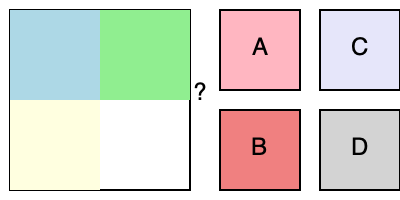Which puzzle piece (A, B, C, or D) correctly completes the jigsaw pattern? Let's approach this step-by-step:

1. Observe the existing pattern:
   - Top-left: Light blue
   - Top-right: Light green
   - Bottom-left: Light yellow
   - Bottom-right: Missing piece (marked with "?")

2. Look for a logical color pattern:
   - The colors are getting progressively lighter and warmer from left to right and top to bottom.

3. Examine the options:
   - A: Light pink
   - B: Light coral (a warmer, more orange-toned pink)
   - C: Lavender (a cool, light purple)
   - D: Light grey

4. Apply the pattern logic:
   - The missing piece should be warmer and lighter than light yellow.
   - Light coral (option B) fits this description best.

5. Double-check:
   - Light pink (A) is not warm enough.
   - Lavender (C) is cooler, not warmer.
   - Light grey (D) doesn't follow the color progression.

Therefore, the correct puzzle piece to complete the pattern is B (light coral).
Answer: B 